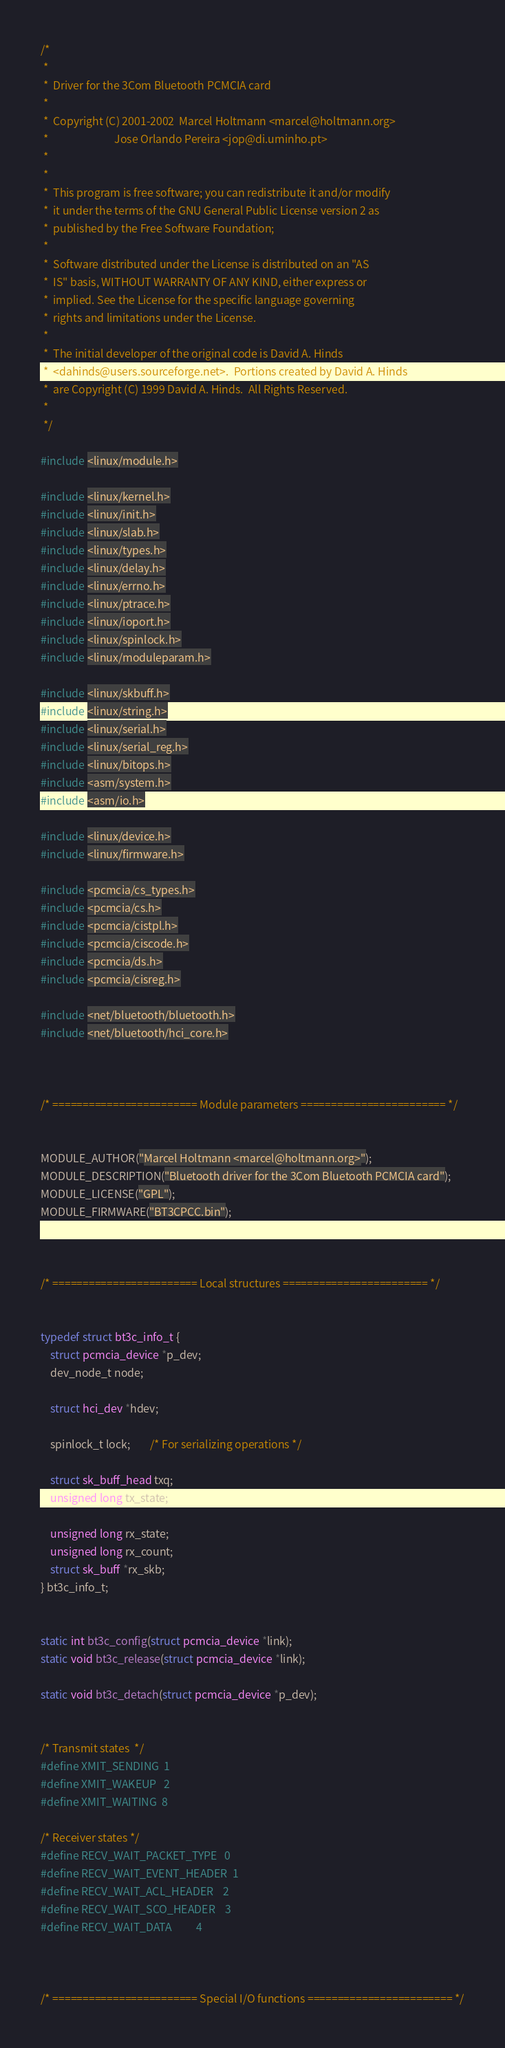<code> <loc_0><loc_0><loc_500><loc_500><_C_>/*
 *
 *  Driver for the 3Com Bluetooth PCMCIA card
 *
 *  Copyright (C) 2001-2002  Marcel Holtmann <marcel@holtmann.org>
 *                           Jose Orlando Pereira <jop@di.uminho.pt>
 *
 *
 *  This program is free software; you can redistribute it and/or modify
 *  it under the terms of the GNU General Public License version 2 as
 *  published by the Free Software Foundation;
 *
 *  Software distributed under the License is distributed on an "AS
 *  IS" basis, WITHOUT WARRANTY OF ANY KIND, either express or
 *  implied. See the License for the specific language governing
 *  rights and limitations under the License.
 *
 *  The initial developer of the original code is David A. Hinds
 *  <dahinds@users.sourceforge.net>.  Portions created by David A. Hinds
 *  are Copyright (C) 1999 David A. Hinds.  All Rights Reserved.
 *
 */

#include <linux/module.h>

#include <linux/kernel.h>
#include <linux/init.h>
#include <linux/slab.h>
#include <linux/types.h>
#include <linux/delay.h>
#include <linux/errno.h>
#include <linux/ptrace.h>
#include <linux/ioport.h>
#include <linux/spinlock.h>
#include <linux/moduleparam.h>

#include <linux/skbuff.h>
#include <linux/string.h>
#include <linux/serial.h>
#include <linux/serial_reg.h>
#include <linux/bitops.h>
#include <asm/system.h>
#include <asm/io.h>

#include <linux/device.h>
#include <linux/firmware.h>

#include <pcmcia/cs_types.h>
#include <pcmcia/cs.h>
#include <pcmcia/cistpl.h>
#include <pcmcia/ciscode.h>
#include <pcmcia/ds.h>
#include <pcmcia/cisreg.h>

#include <net/bluetooth/bluetooth.h>
#include <net/bluetooth/hci_core.h>



/* ======================== Module parameters ======================== */


MODULE_AUTHOR("Marcel Holtmann <marcel@holtmann.org>");
MODULE_DESCRIPTION("Bluetooth driver for the 3Com Bluetooth PCMCIA card");
MODULE_LICENSE("GPL");
MODULE_FIRMWARE("BT3CPCC.bin");



/* ======================== Local structures ======================== */


typedef struct bt3c_info_t {
	struct pcmcia_device *p_dev;
	dev_node_t node;

	struct hci_dev *hdev;

	spinlock_t lock;		/* For serializing operations */

	struct sk_buff_head txq;
	unsigned long tx_state;

	unsigned long rx_state;
	unsigned long rx_count;
	struct sk_buff *rx_skb;
} bt3c_info_t;


static int bt3c_config(struct pcmcia_device *link);
static void bt3c_release(struct pcmcia_device *link);

static void bt3c_detach(struct pcmcia_device *p_dev);


/* Transmit states  */
#define XMIT_SENDING  1
#define XMIT_WAKEUP   2
#define XMIT_WAITING  8

/* Receiver states */
#define RECV_WAIT_PACKET_TYPE   0
#define RECV_WAIT_EVENT_HEADER  1
#define RECV_WAIT_ACL_HEADER    2
#define RECV_WAIT_SCO_HEADER    3
#define RECV_WAIT_DATA          4



/* ======================== Special I/O functions ======================== */

</code> 